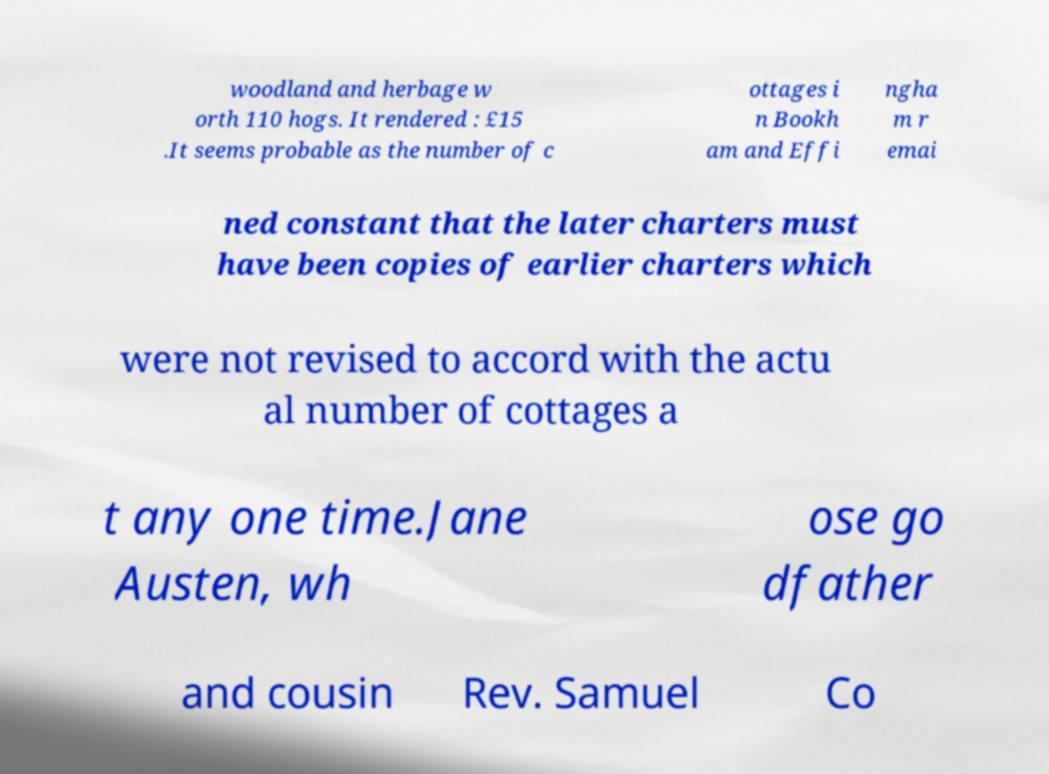I need the written content from this picture converted into text. Can you do that? woodland and herbage w orth 110 hogs. It rendered : £15 .It seems probable as the number of c ottages i n Bookh am and Effi ngha m r emai ned constant that the later charters must have been copies of earlier charters which were not revised to accord with the actu al number of cottages a t any one time.Jane Austen, wh ose go dfather and cousin Rev. Samuel Co 